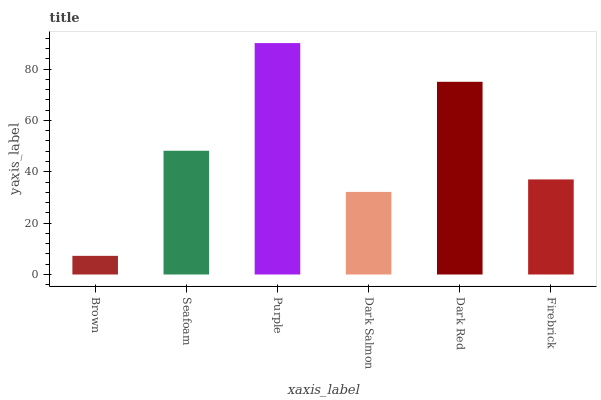Is Brown the minimum?
Answer yes or no. Yes. Is Purple the maximum?
Answer yes or no. Yes. Is Seafoam the minimum?
Answer yes or no. No. Is Seafoam the maximum?
Answer yes or no. No. Is Seafoam greater than Brown?
Answer yes or no. Yes. Is Brown less than Seafoam?
Answer yes or no. Yes. Is Brown greater than Seafoam?
Answer yes or no. No. Is Seafoam less than Brown?
Answer yes or no. No. Is Seafoam the high median?
Answer yes or no. Yes. Is Firebrick the low median?
Answer yes or no. Yes. Is Dark Red the high median?
Answer yes or no. No. Is Purple the low median?
Answer yes or no. No. 